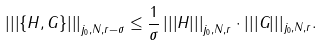Convert formula to latex. <formula><loc_0><loc_0><loc_500><loc_500>\left | \left | \left | \left \{ H , G \right \} \right | \right | \right | _ { j _ { 0 } , N , r - \sigma } \leq \frac { 1 } \sigma \left | \left | \left | H \right | \right | \right | _ { j _ { 0 } , N , r } \cdot | | | G | | | _ { j _ { 0 } , N , r } .</formula> 